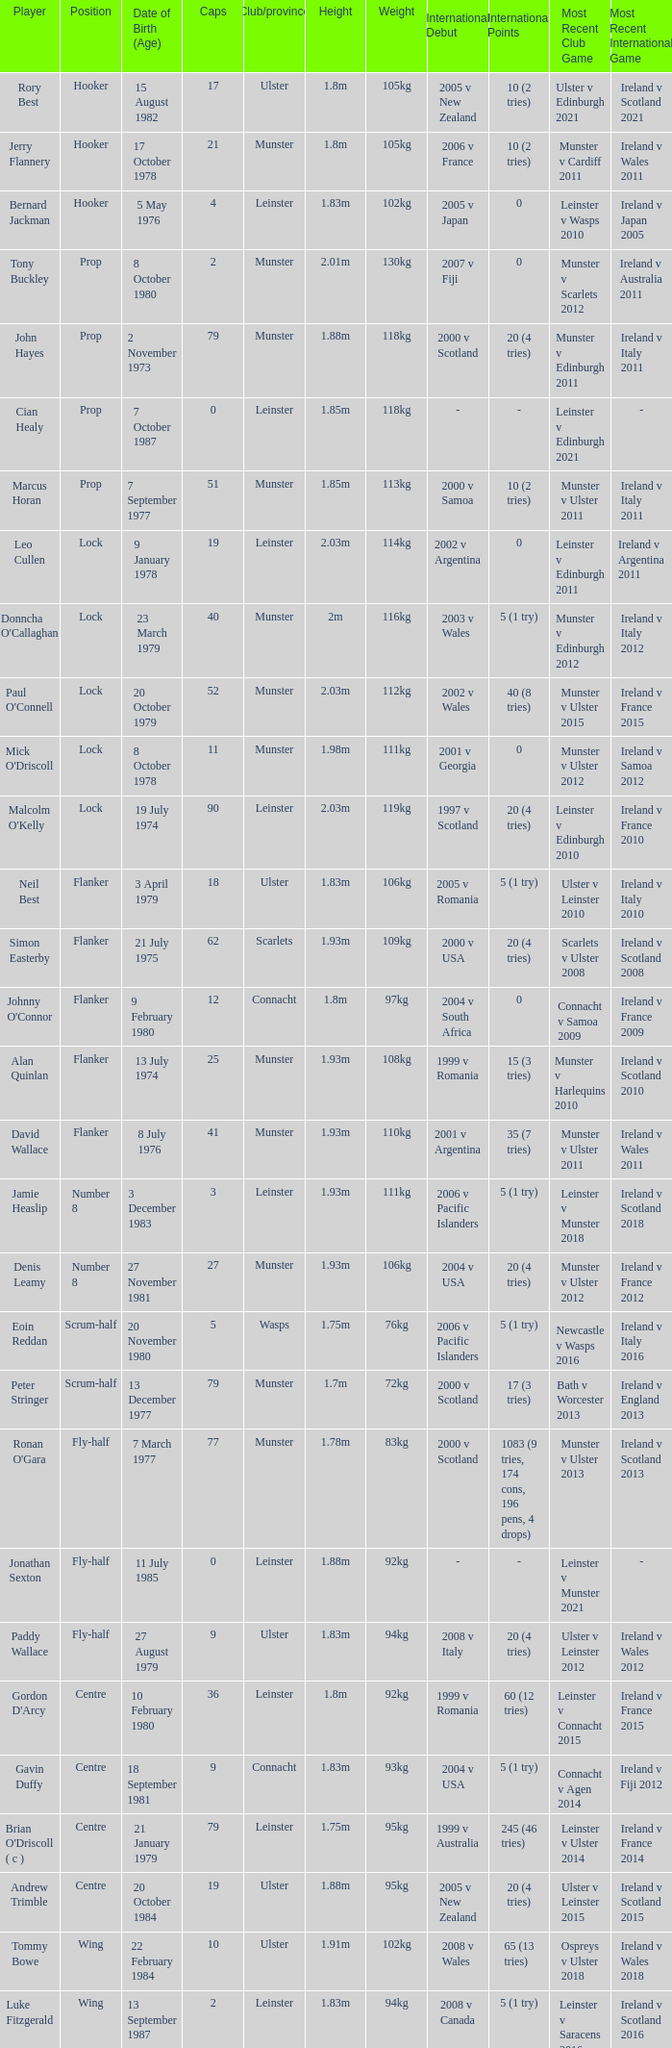Paddy Wallace who plays the position of fly-half has how many Caps? 9.0. Give me the full table as a dictionary. {'header': ['Player', 'Position', 'Date of Birth (Age)', 'Caps', 'Club/province', 'Height', 'Weight', 'International Debut', 'International Points', 'Most Recent Club Game', 'Most Recent International Game'], 'rows': [['Rory Best', 'Hooker', '15 August 1982', '17', 'Ulster', '1.8m', '105kg', '2005 v New Zealand', '10 (2 tries)', 'Ulster v Edinburgh 2021', 'Ireland v Scotland 2021'], ['Jerry Flannery', 'Hooker', '17 October 1978', '21', 'Munster', '1.8m', '105kg', '2006 v France', '10 (2 tries)', 'Munster v Cardiff 2011', 'Ireland v Wales 2011'], ['Bernard Jackman', 'Hooker', '5 May 1976', '4', 'Leinster', '1.83m', '102kg', '2005 v Japan', '0', 'Leinster v Wasps 2010', 'Ireland v Japan 2005'], ['Tony Buckley', 'Prop', '8 October 1980', '2', 'Munster', '2.01m', '130kg', '2007 v Fiji', '0', 'Munster v Scarlets 2012', 'Ireland v Australia 2011'], ['John Hayes', 'Prop', '2 November 1973', '79', 'Munster', '1.88m', '118kg', '2000 v Scotland', '20 (4 tries)', 'Munster v Edinburgh 2011', 'Ireland v Italy 2011'], ['Cian Healy', 'Prop', '7 October 1987', '0', 'Leinster', '1.85m', '118kg', '-', '-', 'Leinster v Edinburgh 2021', '-'], ['Marcus Horan', 'Prop', '7 September 1977', '51', 'Munster', '1.85m', '113kg', '2000 v Samoa', '10 (2 tries)', 'Munster v Ulster 2011', 'Ireland v Italy 2011'], ['Leo Cullen', 'Lock', '9 January 1978', '19', 'Leinster', '2.03m', '114kg', '2002 v Argentina', '0', 'Leinster v Edinburgh 2011', 'Ireland v Argentina 2011'], ["Donncha O'Callaghan", 'Lock', '23 March 1979', '40', 'Munster', '2m', '116kg', '2003 v Wales', '5 (1 try)', 'Munster v Edinburgh 2012', 'Ireland v Italy 2012'], ["Paul O'Connell", 'Lock', '20 October 1979', '52', 'Munster', '2.03m', '112kg', '2002 v Wales', '40 (8 tries)', 'Munster v Ulster 2015', 'Ireland v France 2015'], ["Mick O'Driscoll", 'Lock', '8 October 1978', '11', 'Munster', '1.98m', '111kg', '2001 v Georgia', '0', 'Munster v Ulster 2012', 'Ireland v Samoa 2012'], ["Malcolm O'Kelly", 'Lock', '19 July 1974', '90', 'Leinster', '2.03m', '119kg', '1997 v Scotland', '20 (4 tries)', 'Leinster v Edinburgh 2010', 'Ireland v France 2010'], ['Neil Best', 'Flanker', '3 April 1979', '18', 'Ulster', '1.83m', '106kg', '2005 v Romania', '5 (1 try)', 'Ulster v Leinster 2010', 'Ireland v Italy 2010'], ['Simon Easterby', 'Flanker', '21 July 1975', '62', 'Scarlets', '1.93m', '109kg', '2000 v USA', '20 (4 tries)', 'Scarlets v Ulster 2008', 'Ireland v Scotland 2008'], ["Johnny O'Connor", 'Flanker', '9 February 1980', '12', 'Connacht', '1.8m', '97kg', '2004 v South Africa', '0', 'Connacht v Samoa 2009', 'Ireland v France 2009'], ['Alan Quinlan', 'Flanker', '13 July 1974', '25', 'Munster', '1.93m', '108kg', '1999 v Romania', '15 (3 tries)', 'Munster v Harlequins 2010', 'Ireland v Scotland 2010'], ['David Wallace', 'Flanker', '8 July 1976', '41', 'Munster', '1.93m', '110kg', '2001 v Argentina', '35 (7 tries)', 'Munster v Ulster 2011', 'Ireland v Wales 2011'], ['Jamie Heaslip', 'Number 8', '3 December 1983', '3', 'Leinster', '1.93m', '111kg', '2006 v Pacific Islanders', '5 (1 try)', 'Leinster v Munster 2018', 'Ireland v Scotland 2018'], ['Denis Leamy', 'Number 8', '27 November 1981', '27', 'Munster', '1.93m', '106kg', '2004 v USA', '20 (4 tries)', 'Munster v Ulster 2012', 'Ireland v France 2012'], ['Eoin Reddan', 'Scrum-half', '20 November 1980', '5', 'Wasps', '1.75m', '76kg', '2006 v Pacific Islanders', '5 (1 try)', 'Newcastle v Wasps 2016', 'Ireland v Italy 2016'], ['Peter Stringer', 'Scrum-half', '13 December 1977', '79', 'Munster', '1.7m', '72kg', '2000 v Scotland', '17 (3 tries)', 'Bath v Worcester 2013', 'Ireland v England 2013'], ["Ronan O'Gara", 'Fly-half', '7 March 1977', '77', 'Munster', '1.78m', '83kg', '2000 v Scotland', '1083 (9 tries, 174 cons, 196 pens, 4 drops)', 'Munster v Ulster 2013', 'Ireland v Scotland 2013'], ['Jonathan Sexton', 'Fly-half', '11 July 1985', '0', 'Leinster', '1.88m', '92kg', '-', '-', 'Leinster v Munster 2021', '-'], ['Paddy Wallace', 'Fly-half', '27 August 1979', '9', 'Ulster', '1.83m', '94kg', '2008 v Italy', '20 (4 tries)', 'Ulster v Leinster 2012', 'Ireland v Wales 2012'], ["Gordon D'Arcy", 'Centre', '10 February 1980', '36', 'Leinster', '1.8m', '92kg', '1999 v Romania', '60 (12 tries)', 'Leinster v Connacht 2015', 'Ireland v France 2015'], ['Gavin Duffy', 'Centre', '18 September 1981', '9', 'Connacht', '1.83m', '93kg', '2004 v USA', '5 (1 try)', 'Connacht v Agen 2014', 'Ireland v Fiji 2012'], ["Brian O'Driscoll ( c )", 'Centre', '21 January 1979', '79', 'Leinster', '1.75m', '95kg', '1999 v Australia', '245 (46 tries)', 'Leinster v Ulster 2014', 'Ireland v France 2014'], ['Andrew Trimble', 'Centre', '20 October 1984', '19', 'Ulster', '1.88m', '95kg', '2005 v New Zealand', '20 (4 tries)', 'Ulster v Leinster 2015', 'Ireland v Scotland 2015'], ['Tommy Bowe', 'Wing', '22 February 1984', '10', 'Ulster', '1.91m', '102kg', '2008 v Wales', '65 (13 tries)', 'Ospreys v Ulster 2018', 'Ireland v Wales 2018'], ['Luke Fitzgerald', 'Wing', '13 September 1987', '2', 'Leinster', '1.83m', '94kg', '2008 v Canada', '5 (1 try)', 'Leinster v Saracens 2016', 'Ireland v Scotland 2016'], ['Shane Horgan', 'Wing', '18 July 1978', '58', 'Leinster', '1.96m', '102kg', '2000 v Scotland', '65 (13 tries)', 'Leinster v Ulster 2012', 'Ireland v Italy 2012'], ['Rob Kearney', 'Wing', '26 March 1986', '1', 'Leinster', '1.88m', '95kg', '2007 v Argentina', '0', 'Leinster v Dragons 2021', 'Ireland v Scotland 2021'], ['Girvan Dempsey', 'Fullback', '2 October 1975', '78', 'Leinster', '1.8m', '89kg', '1998 v Georgia', '25 (5 tries)', 'Leinster v Munster 2009', 'Ireland v Scotland 2009'], ['Geordan Murphy', 'Fullback', '19 April 1978', '53', 'Leicester', '1.88m', '87kg', '2000 v Samoa', '32 (8 tries)', 'Leicester v Wasps 2013', 'Ireland v Italy 2011']]} 